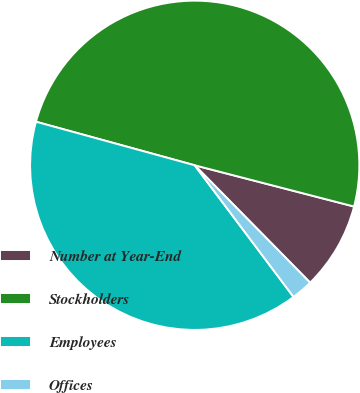Convert chart. <chart><loc_0><loc_0><loc_500><loc_500><pie_chart><fcel>Number at Year-End<fcel>Stockholders<fcel>Employees<fcel>Offices<nl><fcel>8.6%<fcel>49.77%<fcel>39.51%<fcel>2.12%<nl></chart> 